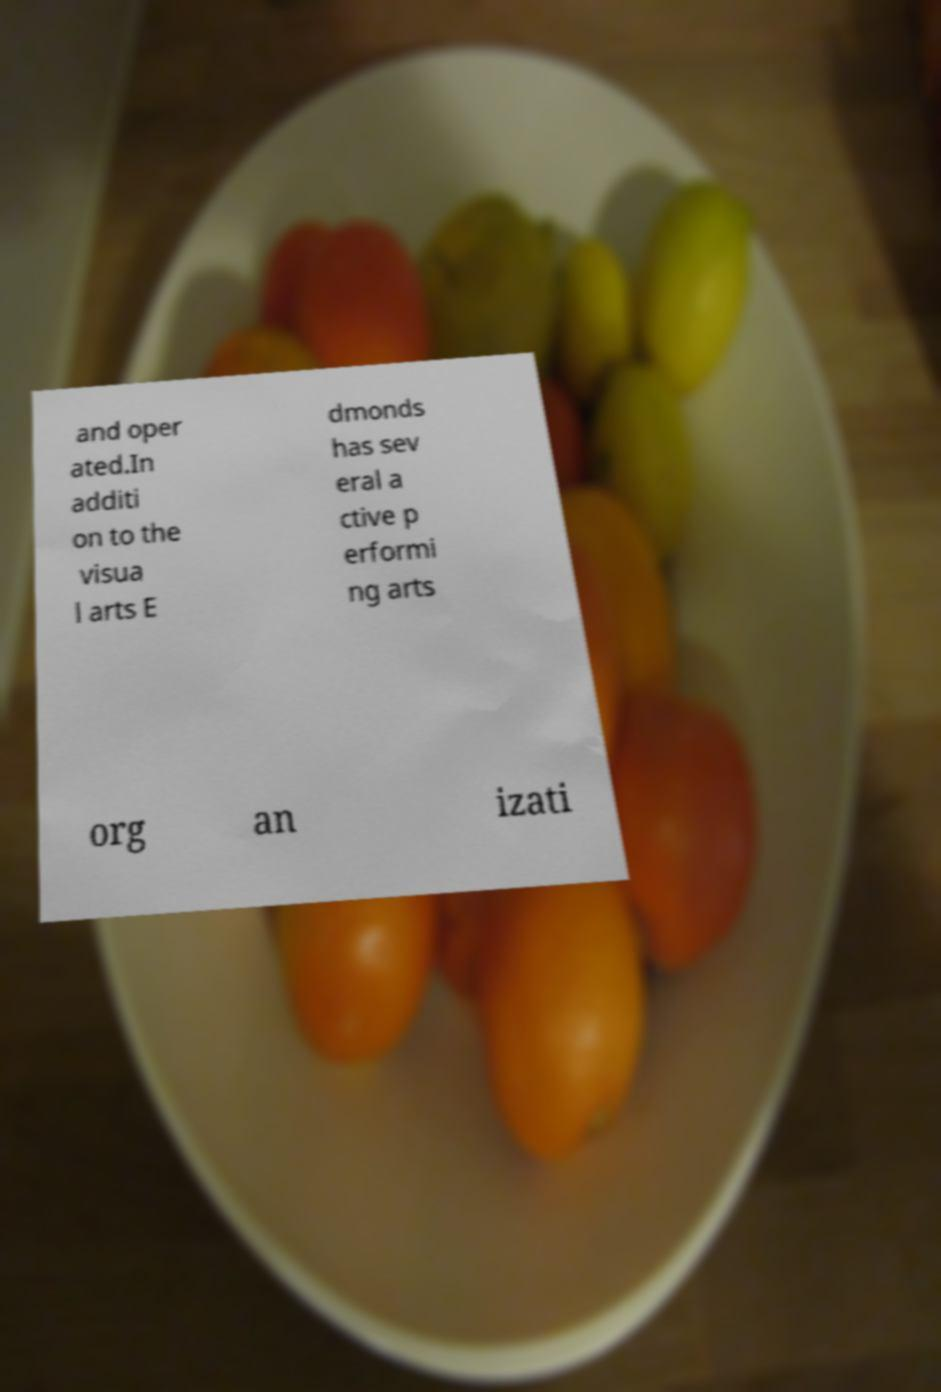Can you read and provide the text displayed in the image?This photo seems to have some interesting text. Can you extract and type it out for me? and oper ated.In additi on to the visua l arts E dmonds has sev eral a ctive p erformi ng arts org an izati 